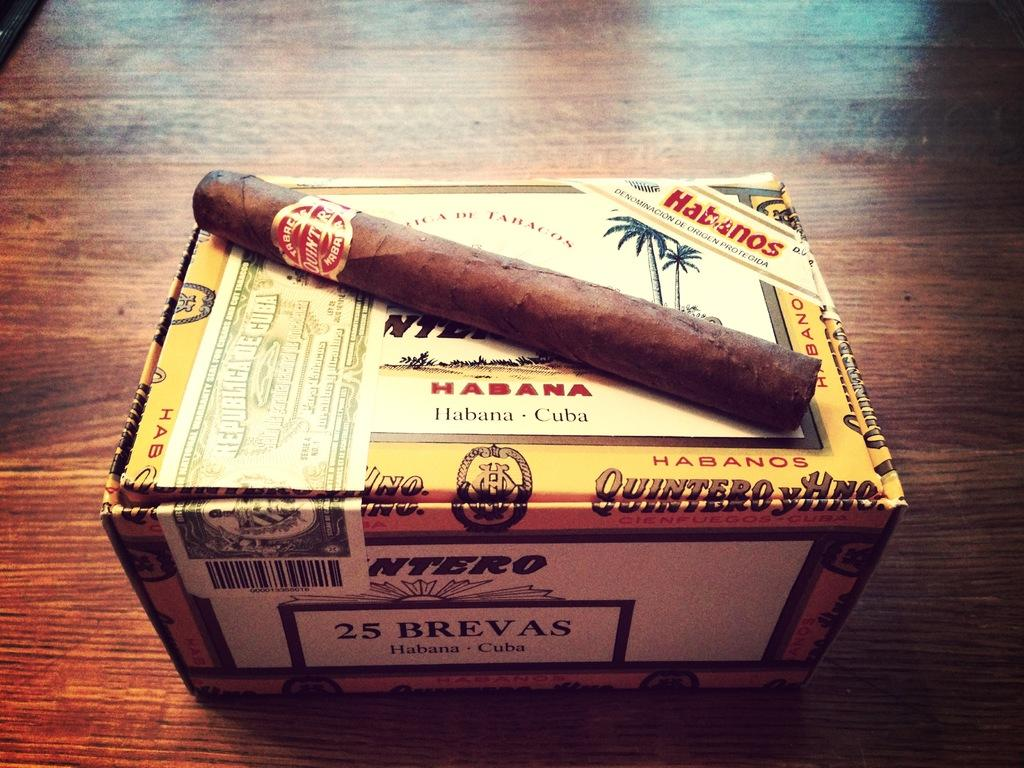<image>
Present a compact description of the photo's key features. a cigar on a box with the label Habanos and Cuba 